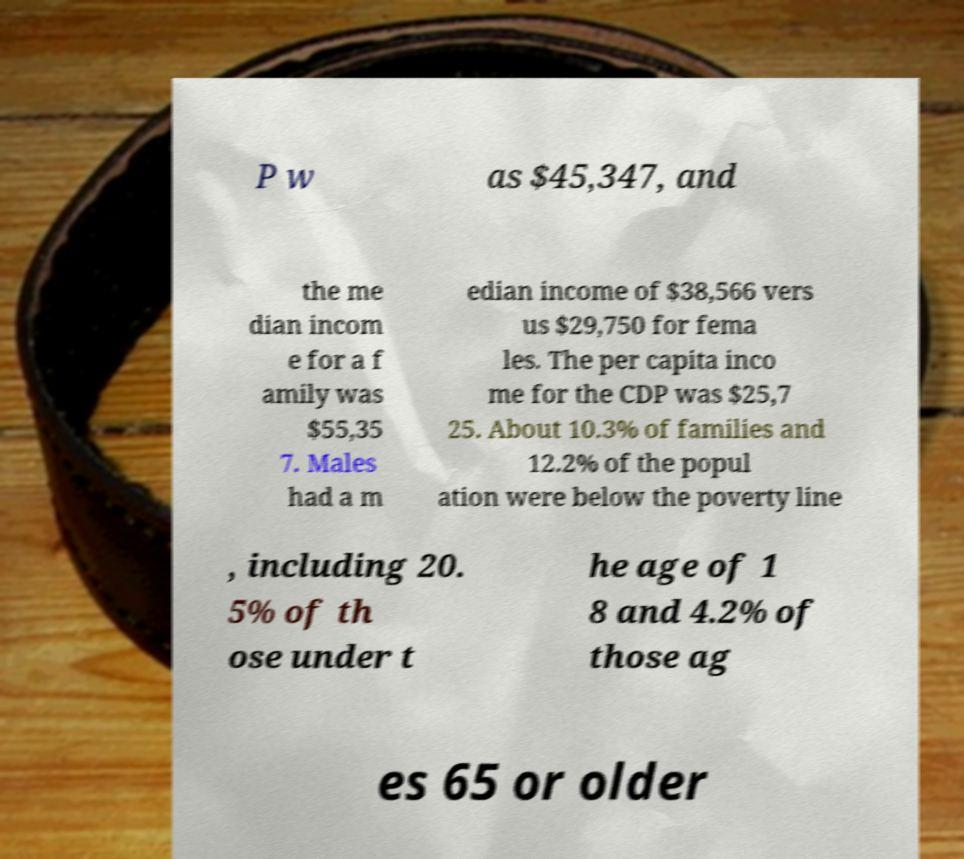For documentation purposes, I need the text within this image transcribed. Could you provide that? P w as $45,347, and the me dian incom e for a f amily was $55,35 7. Males had a m edian income of $38,566 vers us $29,750 for fema les. The per capita inco me for the CDP was $25,7 25. About 10.3% of families and 12.2% of the popul ation were below the poverty line , including 20. 5% of th ose under t he age of 1 8 and 4.2% of those ag es 65 or older 